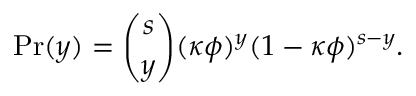<formula> <loc_0><loc_0><loc_500><loc_500>P r ( y ) = \binom { s } { y } ( \kappa \phi ) ^ { y } ( 1 - \kappa \phi ) ^ { s - y } .</formula> 